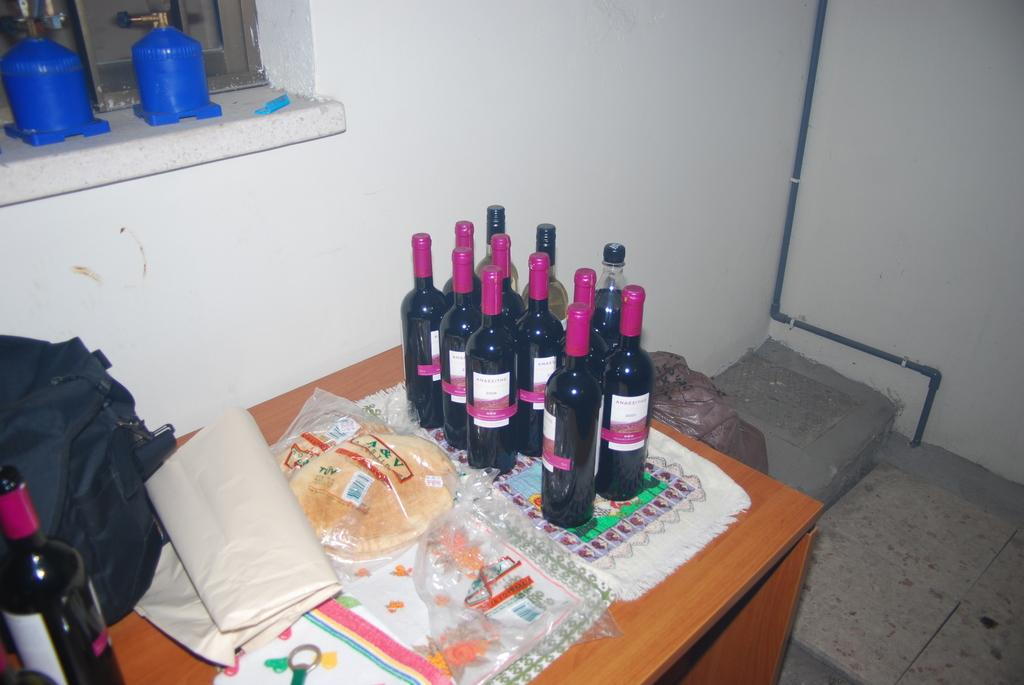What objects are on the table in the image? There are bottles on the table. What type of memory can be seen in the image? There is no memory present in the image; it features bottles on a table. What is the level of friction between the bottles in the image? The level of friction between the bottles cannot be determined from the image, as it does not provide information about their physical interaction. 